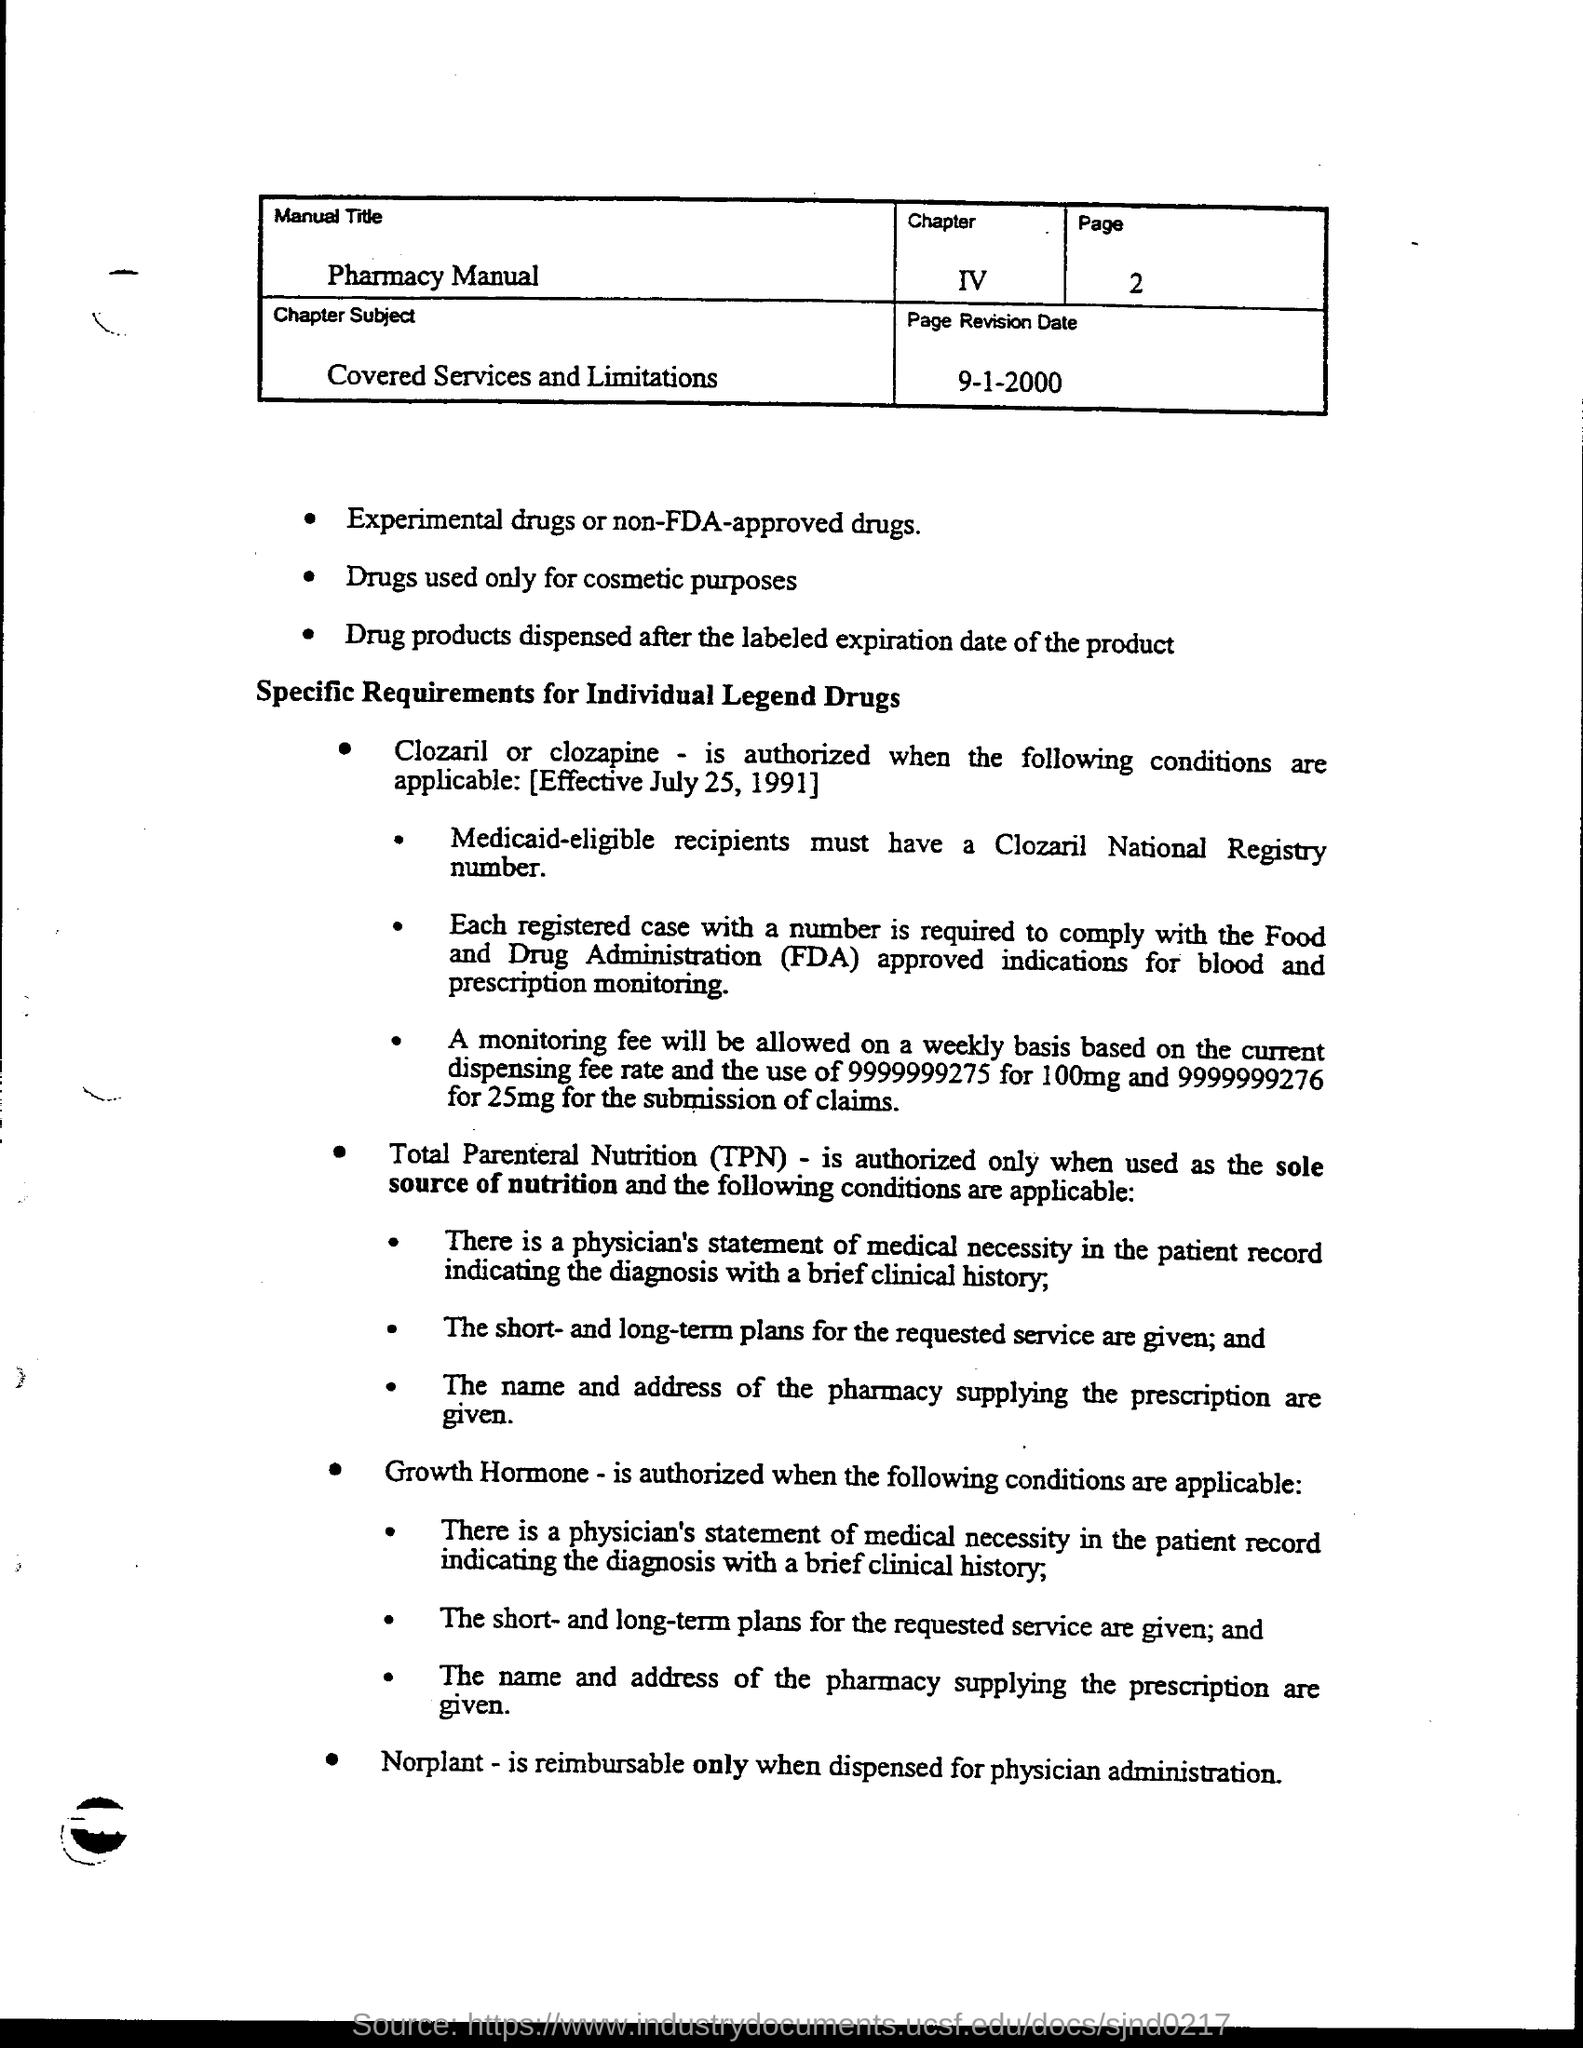Identify some key points in this picture. 2" is the page number, according to the context provided. The chapter number is IV. What is the page revision date?" is a question that requires a response that provides information about the date of the most recent update or modification to a particular page. The specific date in question is "9-1-2000. The manual title is "Pharmacy Manual. The Food and Drug Administration (FDA) is a government agency responsible for regulating and overseeing the safety and efficacy of food and drugs in the United States. 